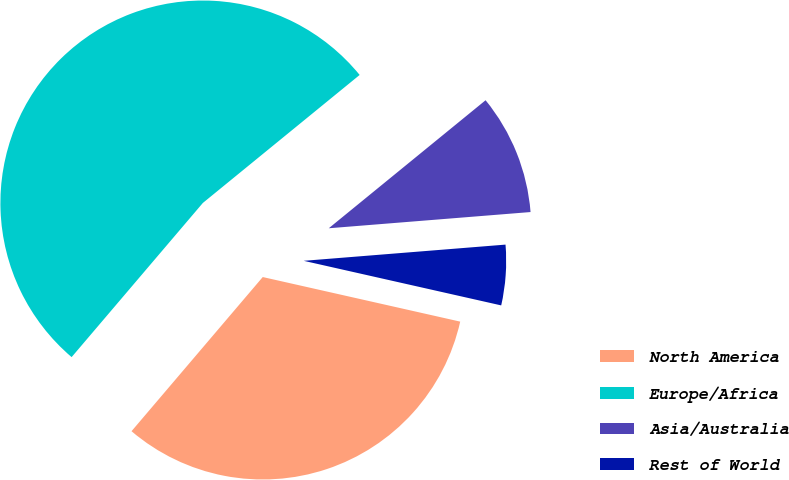<chart> <loc_0><loc_0><loc_500><loc_500><pie_chart><fcel>North America<fcel>Europe/Africa<fcel>Asia/Australia<fcel>Rest of World<nl><fcel>32.69%<fcel>52.88%<fcel>9.62%<fcel>4.81%<nl></chart> 